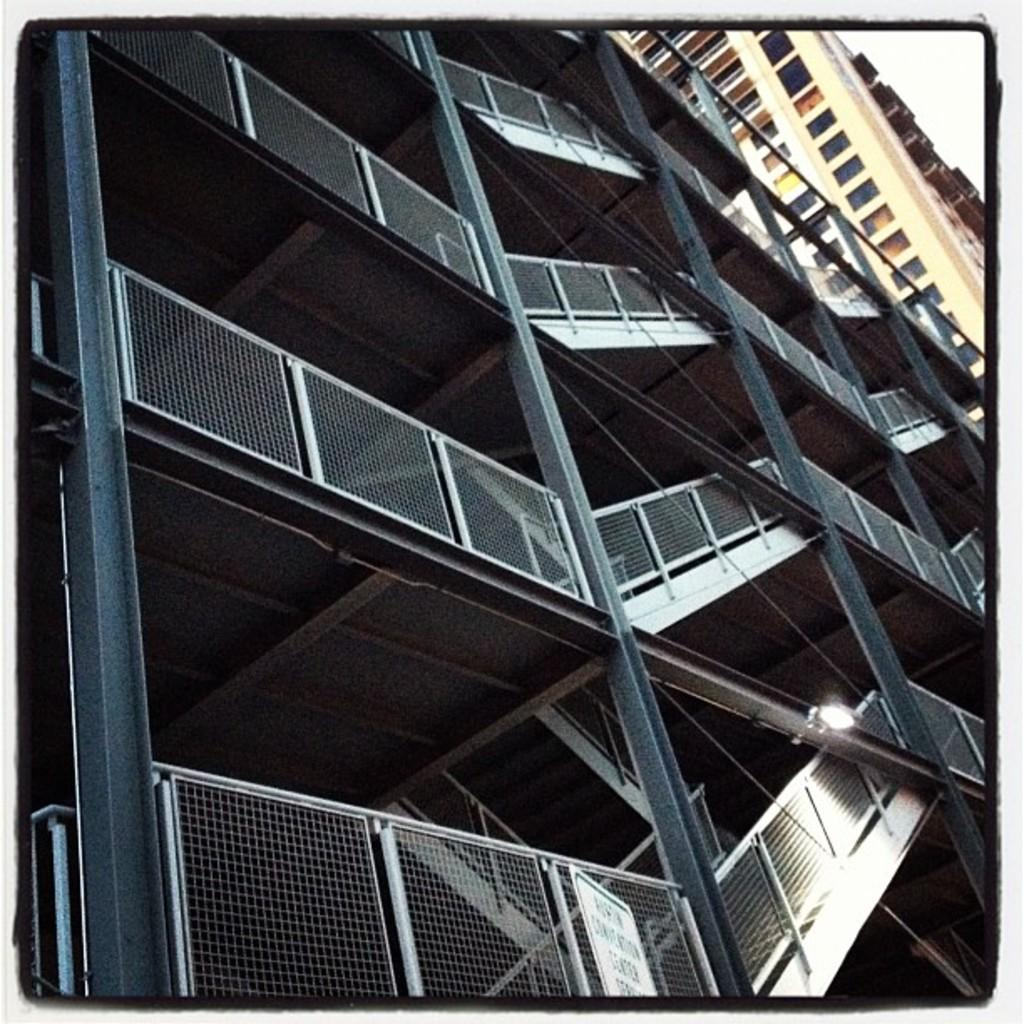What is the main structure in the center of the image? There is a building in the center of the image. What architectural feature can be seen in the image? There are staircases in the image. Where is the rabbit hiding in the image? There is no rabbit present in the image. What type of rice is being served at the event in the image? There is no event or rice present in the image. 